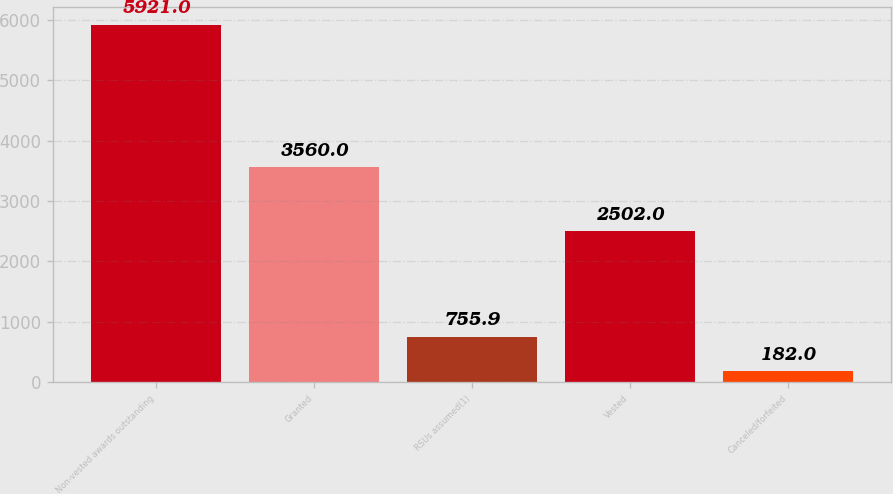<chart> <loc_0><loc_0><loc_500><loc_500><bar_chart><fcel>Non-vested awards outstanding<fcel>Granted<fcel>RSUs assumed(1)<fcel>Vested<fcel>Canceled/forfeited<nl><fcel>5921<fcel>3560<fcel>755.9<fcel>2502<fcel>182<nl></chart> 